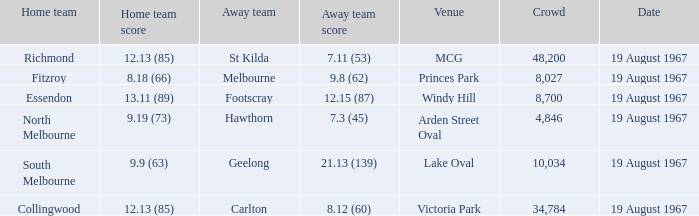If the opposing team scored 9.19 (73). 